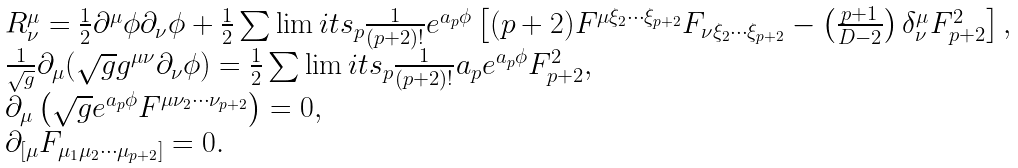Convert formula to latex. <formula><loc_0><loc_0><loc_500><loc_500>\begin{array} { l } R ^ { \mu } _ { \nu } = \frac { 1 } { 2 } \partial ^ { \mu } \phi \partial _ { \nu } \phi + \frac { 1 } { 2 } \sum \lim i t s _ { p } \frac { 1 } { ( p + 2 ) ! } e ^ { a _ { p } \phi } \left [ ( p + 2 ) F ^ { \mu \xi _ { 2 } \cdots \xi _ { p + 2 } } F _ { \nu \xi _ { 2 } \cdots \xi _ { p + 2 } } - \left ( \frac { p + 1 } { D - 2 } \right ) \delta _ { \nu } ^ { \mu } F ^ { 2 } _ { p + 2 } \right ] , \\ \frac { 1 } { \sqrt { g } } \partial _ { \mu } ( \sqrt { g } g ^ { \mu \nu } \partial _ { \nu } \phi ) = \frac { 1 } { 2 } \sum \lim i t s _ { p } \frac { 1 } { ( p + 2 ) ! } a _ { p } e ^ { a _ { p } \phi } F _ { p + 2 } ^ { 2 } , \\ \partial _ { \mu } \left ( \sqrt { g } e ^ { a _ { p } \phi } F ^ { \mu \nu _ { 2 } \cdots \nu _ { p + 2 } } \right ) = 0 , \\ \partial _ { { [ } \mu } F _ { \mu _ { 1 } \mu _ { 2 } \cdots \mu _ { p + 2 } { ] } } = 0 . \end{array}</formula> 